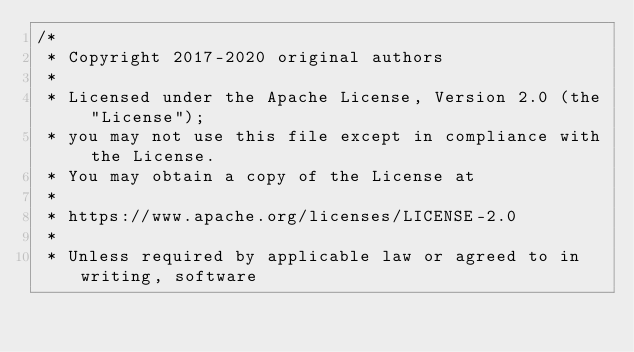<code> <loc_0><loc_0><loc_500><loc_500><_Java_>/*
 * Copyright 2017-2020 original authors
 *
 * Licensed under the Apache License, Version 2.0 (the "License");
 * you may not use this file except in compliance with the License.
 * You may obtain a copy of the License at
 *
 * https://www.apache.org/licenses/LICENSE-2.0
 *
 * Unless required by applicable law or agreed to in writing, software</code> 